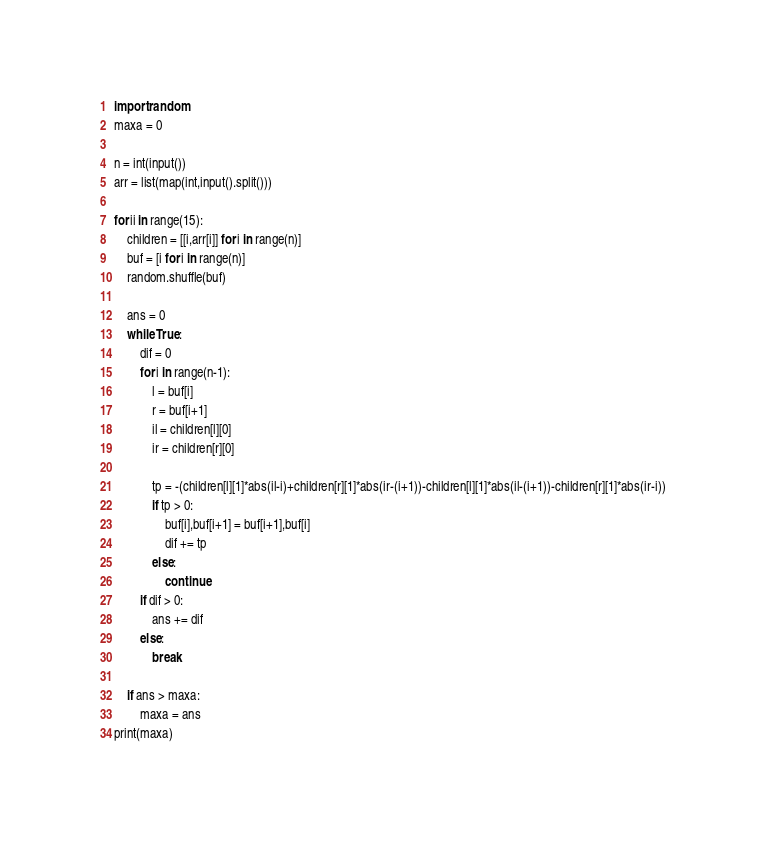<code> <loc_0><loc_0><loc_500><loc_500><_Python_>import random
maxa = 0

n = int(input())
arr = list(map(int,input().split()))

for ii in range(15):
    children = [[i,arr[i]] for i in range(n)]
    buf = [i for i in range(n)]
    random.shuffle(buf)

    ans = 0
    while True:
        dif = 0
        for i in range(n-1):
            l = buf[i]
            r = buf[i+1]
            il = children[l][0]
            ir = children[r][0]

            tp = -(children[l][1]*abs(il-i)+children[r][1]*abs(ir-(i+1))-children[l][1]*abs(il-(i+1))-children[r][1]*abs(ir-i))
            if tp > 0:
                buf[i],buf[i+1] = buf[i+1],buf[i]
                dif += tp
            else:
                continue
        if dif > 0:
            ans += dif
        else:
            break

    if ans > maxa:
        maxa = ans
print(maxa)</code> 